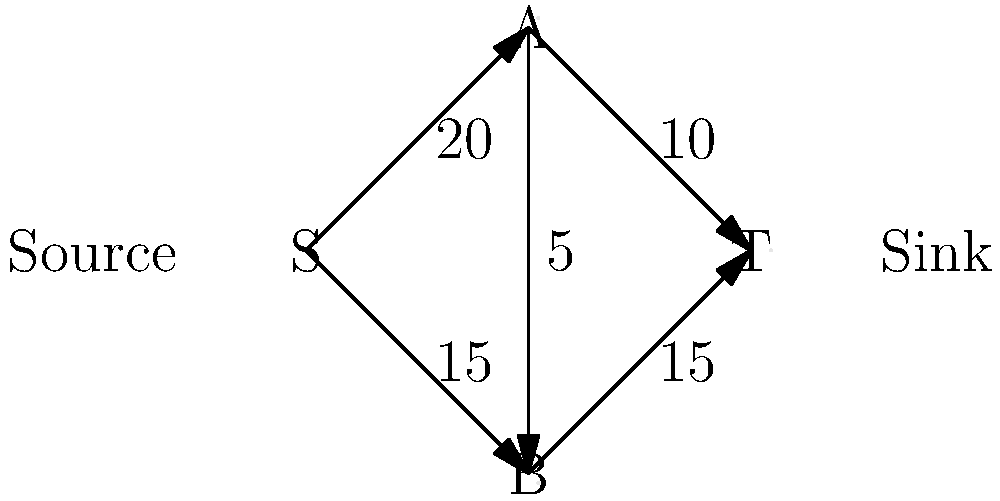During a major fashion week event, you need to manage the bandwidth requirements for different hair styling stations. The network flow diagram represents the bandwidth capacity (in Mbps) between stations. What is the maximum total bandwidth that can be utilized from the source (S) to the sink (T)? To solve this problem, we need to find the maximum flow from the source (S) to the sink (T) in the given network. We'll use the Ford-Fulkerson algorithm:

1. Identify all possible paths from S to T:
   Path 1: S → A → T (min capacity: 10 Mbps)
   Path 2: S → B → T (min capacity: 15 Mbps)
   Path 3: S → A → B → T (min capacity: 5 Mbps)

2. Start with zero flow and augment along each path:
   Path 1: Augment by 10 Mbps
   Total flow: 10 Mbps
   Residual capacities: S→A: 10, A→T: 0, S→B: 15, B→T: 15, A→B: 5

   Path 2: Augment by 15 Mbps
   Total flow: 25 Mbps
   Residual capacities: S→A: 10, A→T: 0, S→B: 0, B→T: 0, A→B: 5

   Path 3: Augment by 5 Mbps
   Total flow: 30 Mbps
   Residual capacities: S→A: 5, A→T: 0, S→B: 0, B→T: 0, A→B: 0

3. No more augmenting paths available, so the maximum flow is 30 Mbps.

This means the maximum total bandwidth that can be utilized from the source (S) to the sink (T) is 30 Mbps.
Answer: 30 Mbps 